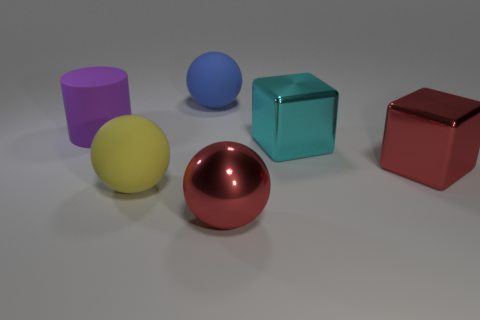Does the red thing that is to the right of the metallic sphere have the same material as the large cylinder?
Provide a short and direct response. No. Is there any other thing that has the same material as the large cylinder?
Offer a terse response. Yes. There is a rubber cylinder that is the same size as the cyan block; what color is it?
Provide a succinct answer. Purple. Is there a rubber thing of the same color as the big rubber cylinder?
Offer a terse response. No. There is a blue sphere that is made of the same material as the big purple object; what is its size?
Make the answer very short. Large. What is the size of the shiny block that is the same color as the metallic ball?
Your response must be concise. Large. How many other objects are the same size as the blue matte thing?
Keep it short and to the point. 5. There is a large sphere on the right side of the large blue ball; what is it made of?
Ensure brevity in your answer.  Metal. There is a large rubber thing that is behind the big thing that is to the left of the rubber ball in front of the large red metallic cube; what is its shape?
Provide a short and direct response. Sphere. Is the purple cylinder the same size as the blue object?
Offer a very short reply. Yes. 